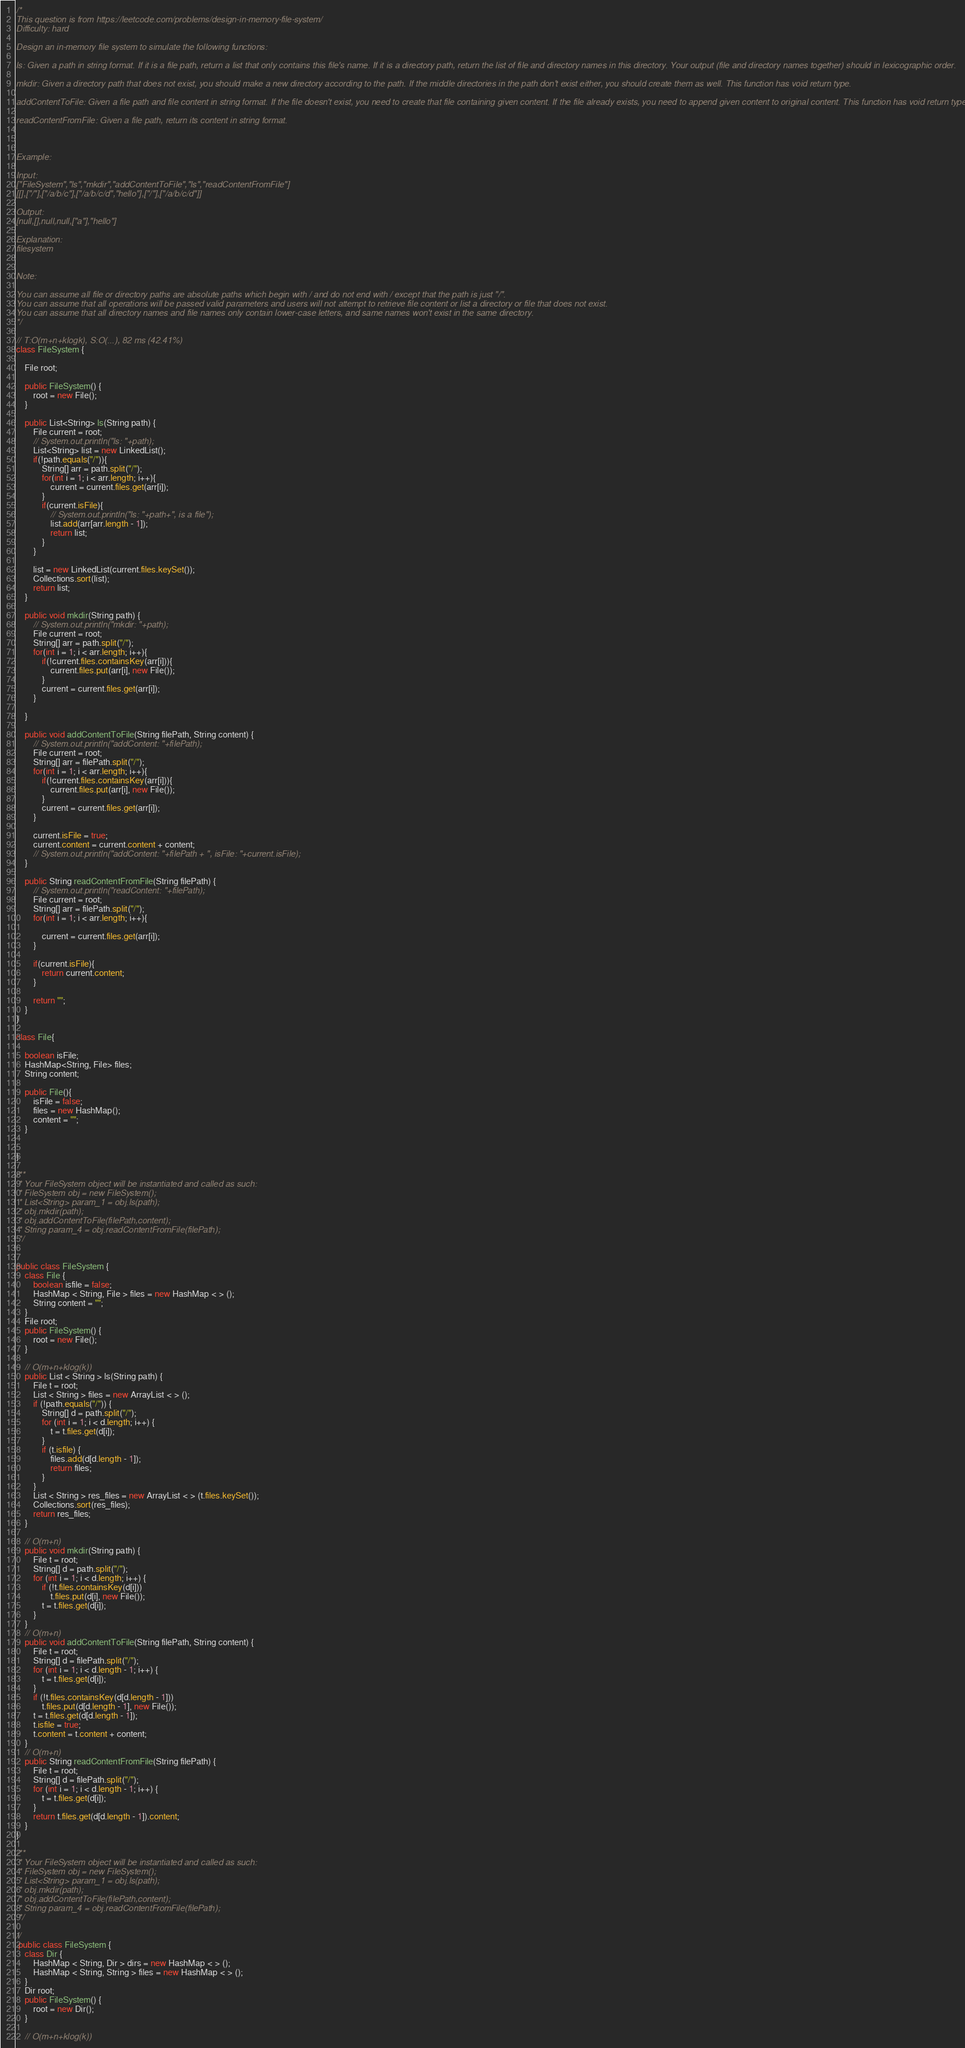Convert code to text. <code><loc_0><loc_0><loc_500><loc_500><_Java_>/*
This question is from https://leetcode.com/problems/design-in-memory-file-system/
Difficulty: hard

Design an in-memory file system to simulate the following functions:

ls: Given a path in string format. If it is a file path, return a list that only contains this file's name. If it is a directory path, return the list of file and directory names in this directory. Your output (file and directory names together) should in lexicographic order.

mkdir: Given a directory path that does not exist, you should make a new directory according to the path. If the middle directories in the path don't exist either, you should create them as well. This function has void return type.

addContentToFile: Given a file path and file content in string format. If the file doesn't exist, you need to create that file containing given content. If the file already exists, you need to append given content to original content. This function has void return type.

readContentFromFile: Given a file path, return its content in string format.



Example:

Input:
["FileSystem","ls","mkdir","addContentToFile","ls","readContentFromFile"]
[[],["/"],["/a/b/c"],["/a/b/c/d","hello"],["/"],["/a/b/c/d"]]

Output:
[null,[],null,null,["a"],"hello"]

Explanation:
filesystem


Note:

You can assume all file or directory paths are absolute paths which begin with / and do not end with / except that the path is just "/".
You can assume that all operations will be passed valid parameters and users will not attempt to retrieve file content or list a directory or file that does not exist.
You can assume that all directory names and file names only contain lower-case letters, and same names won't exist in the same directory.
*/

// T:O(m+n+klogk), S:O(...), 82 ms (42.41%)
class FileSystem {

    File root;

    public FileSystem() {
        root = new File();
    }

    public List<String> ls(String path) {
        File current = root;
        // System.out.println("ls: "+path);
        List<String> list = new LinkedList();
        if(!path.equals("/")){
            String[] arr = path.split("/");
            for(int i = 1; i < arr.length; i++){
                current = current.files.get(arr[i]);
            }
            if(current.isFile){
                // System.out.println("ls: "+path+", is a file");
                list.add(arr[arr.length - 1]);
                return list;
            }
        }

        list = new LinkedList(current.files.keySet());
        Collections.sort(list);
        return list;
    }

    public void mkdir(String path) {
        // System.out.println("mkdir: "+path);
        File current = root;
        String[] arr = path.split("/");
        for(int i = 1; i < arr.length; i++){
            if(!current.files.containsKey(arr[i])){
                current.files.put(arr[i], new File());
            }
            current = current.files.get(arr[i]);
        }

    }

    public void addContentToFile(String filePath, String content) {
        // System.out.println("addContent: "+filePath);
        File current = root;
        String[] arr = filePath.split("/");
        for(int i = 1; i < arr.length; i++){
            if(!current.files.containsKey(arr[i])){
                current.files.put(arr[i], new File());
            }
            current = current.files.get(arr[i]);
        }

        current.isFile = true;
        current.content = current.content + content;
        // System.out.println("addContent: "+filePath + ", isFile: "+current.isFile);
    }

    public String readContentFromFile(String filePath) {
        // System.out.println("readContent: "+filePath);
        File current = root;
        String[] arr = filePath.split("/");
        for(int i = 1; i < arr.length; i++){

            current = current.files.get(arr[i]);
        }

        if(current.isFile){
            return current.content;
        }

        return "";
    }
}

class File{

    boolean isFile;
    HashMap<String, File> files;
    String content;

    public File(){
        isFile = false;
        files = new HashMap();
        content = "";
    }


}

/**
 * Your FileSystem object will be instantiated and called as such:
 * FileSystem obj = new FileSystem();
 * List<String> param_1 = obj.ls(path);
 * obj.mkdir(path);
 * obj.addContentToFile(filePath,content);
 * String param_4 = obj.readContentFromFile(filePath);
 */


public class FileSystem {
    class File {
        boolean isfile = false;
        HashMap < String, File > files = new HashMap < > ();
        String content = "";
    }
    File root;
    public FileSystem() {
        root = new File();
    }

    // O(m+n+klog(k))
    public List < String > ls(String path) {
        File t = root;
        List < String > files = new ArrayList < > ();
        if (!path.equals("/")) {
            String[] d = path.split("/");
            for (int i = 1; i < d.length; i++) {
                t = t.files.get(d[i]);
            }
            if (t.isfile) {
                files.add(d[d.length - 1]);
                return files;
            }
        }
        List < String > res_files = new ArrayList < > (t.files.keySet());
        Collections.sort(res_files);
        return res_files;
    }

    // O(m+n)
    public void mkdir(String path) {
        File t = root;
        String[] d = path.split("/");
        for (int i = 1; i < d.length; i++) {
            if (!t.files.containsKey(d[i]))
                t.files.put(d[i], new File());
            t = t.files.get(d[i]);
        }
    }
    // O(m+n)
    public void addContentToFile(String filePath, String content) {
        File t = root;
        String[] d = filePath.split("/");
        for (int i = 1; i < d.length - 1; i++) {
            t = t.files.get(d[i]);
        }
        if (!t.files.containsKey(d[d.length - 1]))
            t.files.put(d[d.length - 1], new File());
        t = t.files.get(d[d.length - 1]);
        t.isfile = true;
        t.content = t.content + content;
    }
    // O(m+n)
    public String readContentFromFile(String filePath) {
        File t = root;
        String[] d = filePath.split("/");
        for (int i = 1; i < d.length - 1; i++) {
            t = t.files.get(d[i]);
        }
        return t.files.get(d[d.length - 1]).content;
    }
}

/**
 * Your FileSystem object will be instantiated and called as such:
 * FileSystem obj = new FileSystem();
 * List<String> param_1 = obj.ls(path);
 * obj.mkdir(path);
 * obj.addContentToFile(filePath,content);
 * String param_4 = obj.readContentFromFile(filePath);
 */

//
 public class FileSystem {
    class Dir {
        HashMap < String, Dir > dirs = new HashMap < > ();
        HashMap < String, String > files = new HashMap < > ();
    }
    Dir root;
    public FileSystem() {
        root = new Dir();
    }

    // O(m+n+klog(k))</code> 